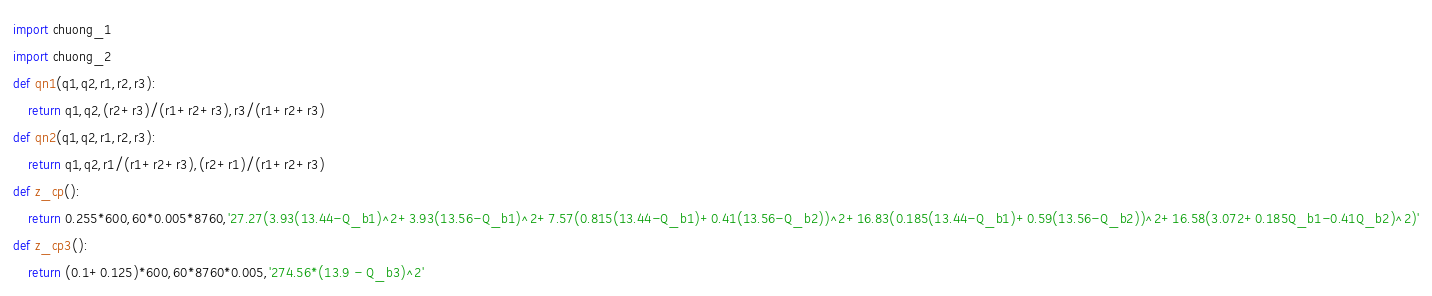Convert code to text. <code><loc_0><loc_0><loc_500><loc_500><_Python_>import chuong_1
import chuong_2
def qn1(q1,q2,r1,r2,r3):
    return q1,q2,(r2+r3)/(r1+r2+r3),r3/(r1+r2+r3)
def qn2(q1,q2,r1,r2,r3):
    return q1,q2,r1/(r1+r2+r3),(r2+r1)/(r1+r2+r3) 
def z_cp():
    return 0.255*600,60*0.005*8760,'27.27(3.93(13.44-Q_b1)^2+3.93(13.56-Q_b1)^2+7.57(0.815(13.44-Q_b1)+0.41(13.56-Q_b2))^2+16.83(0.185(13.44-Q_b1)+0.59(13.56-Q_b2))^2+16.58(3.072+0.185Q_b1-0.41Q_b2)^2)'
def z_cp3():
    return (0.1+0.125)*600,60*8760*0.005,'274.56*(13.9 - Q_b3)^2'</code> 